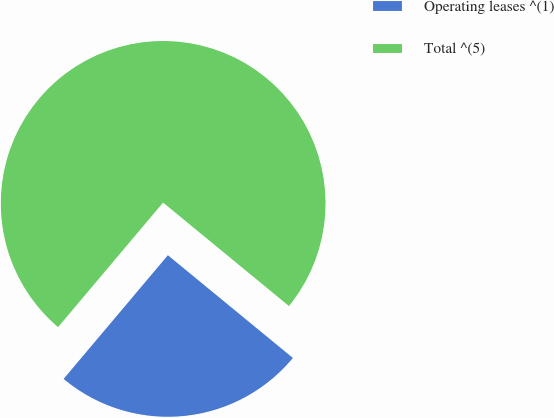<chart> <loc_0><loc_0><loc_500><loc_500><pie_chart><fcel>Operating leases ^(1)<fcel>Total ^(5)<nl><fcel>25.2%<fcel>74.8%<nl></chart> 